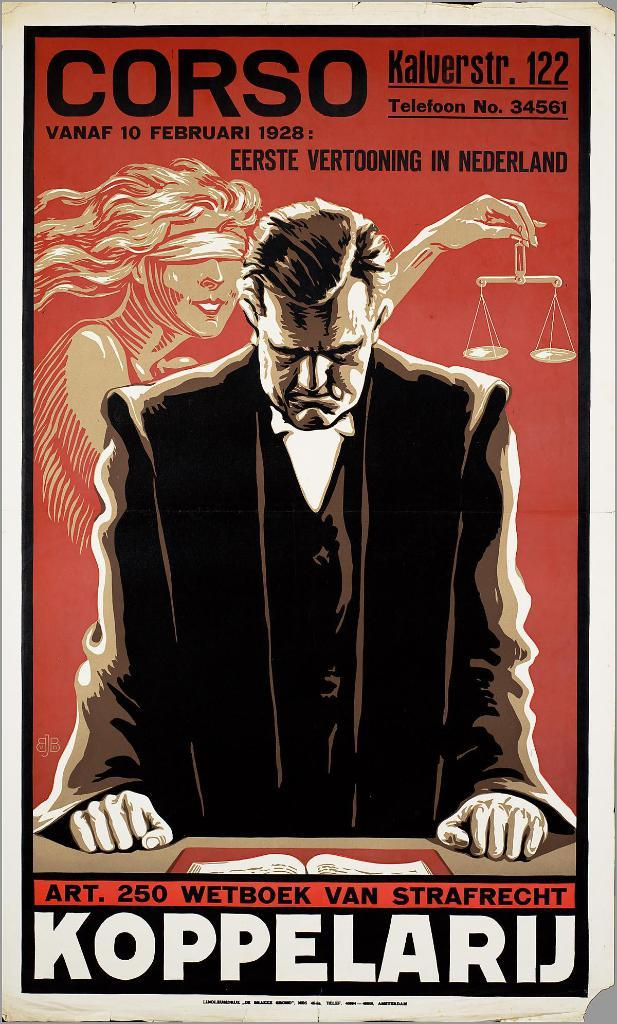<image>
Create a compact narrative representing the image presented. a red sign with the number 250 near the bottom 